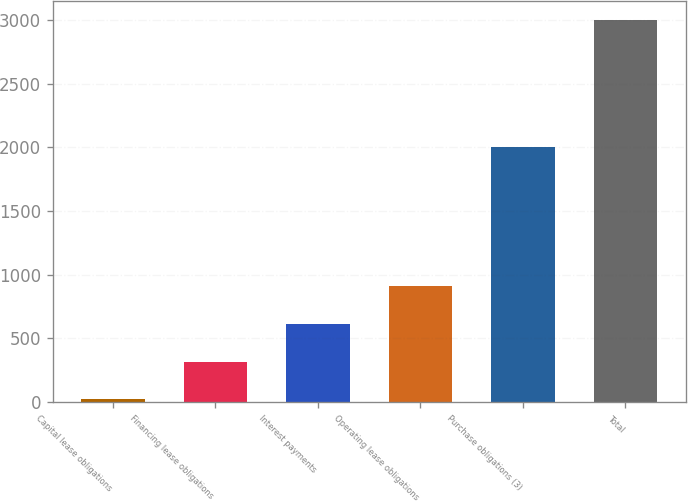Convert chart. <chart><loc_0><loc_0><loc_500><loc_500><bar_chart><fcel>Capital lease obligations<fcel>Financing lease obligations<fcel>Interest payments<fcel>Operating lease obligations<fcel>Purchase obligations (3)<fcel>Total<nl><fcel>20<fcel>317.9<fcel>615.8<fcel>913.7<fcel>2004<fcel>2999<nl></chart> 